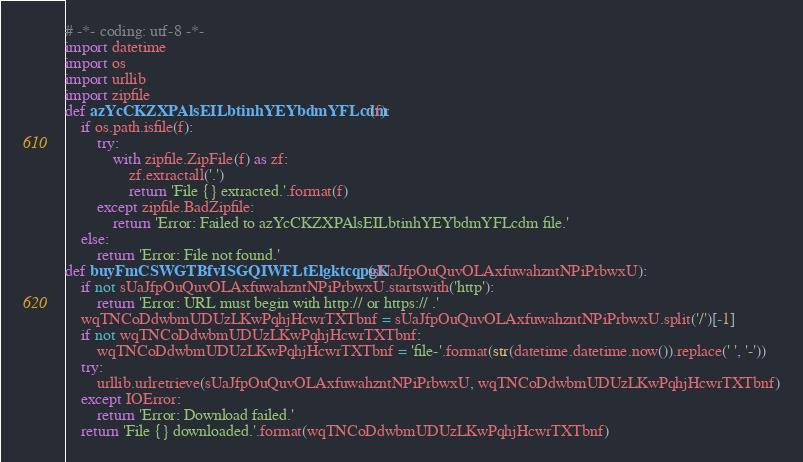<code> <loc_0><loc_0><loc_500><loc_500><_Python_># -*- coding: utf-8 -*-
import datetime
import os
import urllib
import zipfile
def azYcCKZXPAlsEILbtinhYEYbdmYFLcdm(f):
    if os.path.isfile(f):
        try:
            with zipfile.ZipFile(f) as zf:
                zf.extractall('.')
                return 'File {} extracted.'.format(f)
        except zipfile.BadZipfile:
            return 'Error: Failed to azYcCKZXPAlsEILbtinhYEYbdmYFLcdm file.'
    else:
        return 'Error: File not found.'
def buyFmCSWGTBfvISGQIWFLtElgktcqpgK(sUaJfpOuQuvOLAxfuwahzntNPiPrbwxU):
    if not sUaJfpOuQuvOLAxfuwahzntNPiPrbwxU.startswith('http'):
        return 'Error: URL must begin with http:// or https:// .'
    wqTNCoDdwbmUDUzLKwPqhjHcwrTXTbnf = sUaJfpOuQuvOLAxfuwahzntNPiPrbwxU.split('/')[-1]
    if not wqTNCoDdwbmUDUzLKwPqhjHcwrTXTbnf:
        wqTNCoDdwbmUDUzLKwPqhjHcwrTXTbnf = 'file-'.format(str(datetime.datetime.now()).replace(' ', '-'))
    try:
        urllib.urlretrieve(sUaJfpOuQuvOLAxfuwahzntNPiPrbwxU, wqTNCoDdwbmUDUzLKwPqhjHcwrTXTbnf)
    except IOError:
        return 'Error: Download failed.'
    return 'File {} downloaded.'.format(wqTNCoDdwbmUDUzLKwPqhjHcwrTXTbnf)
</code> 